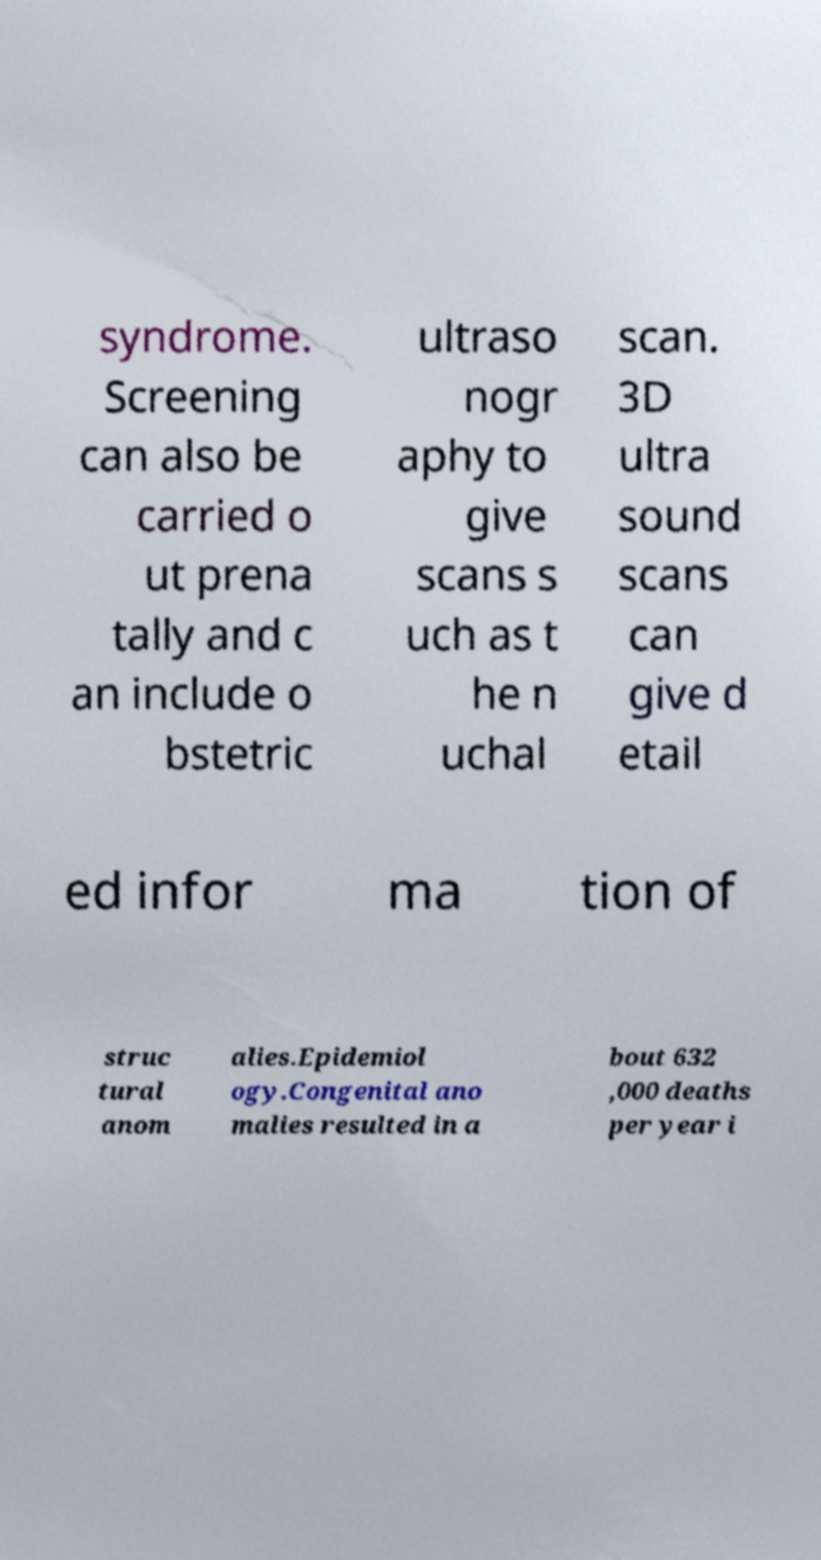What messages or text are displayed in this image? I need them in a readable, typed format. syndrome. Screening can also be carried o ut prena tally and c an include o bstetric ultraso nogr aphy to give scans s uch as t he n uchal scan. 3D ultra sound scans can give d etail ed infor ma tion of struc tural anom alies.Epidemiol ogy.Congenital ano malies resulted in a bout 632 ,000 deaths per year i 